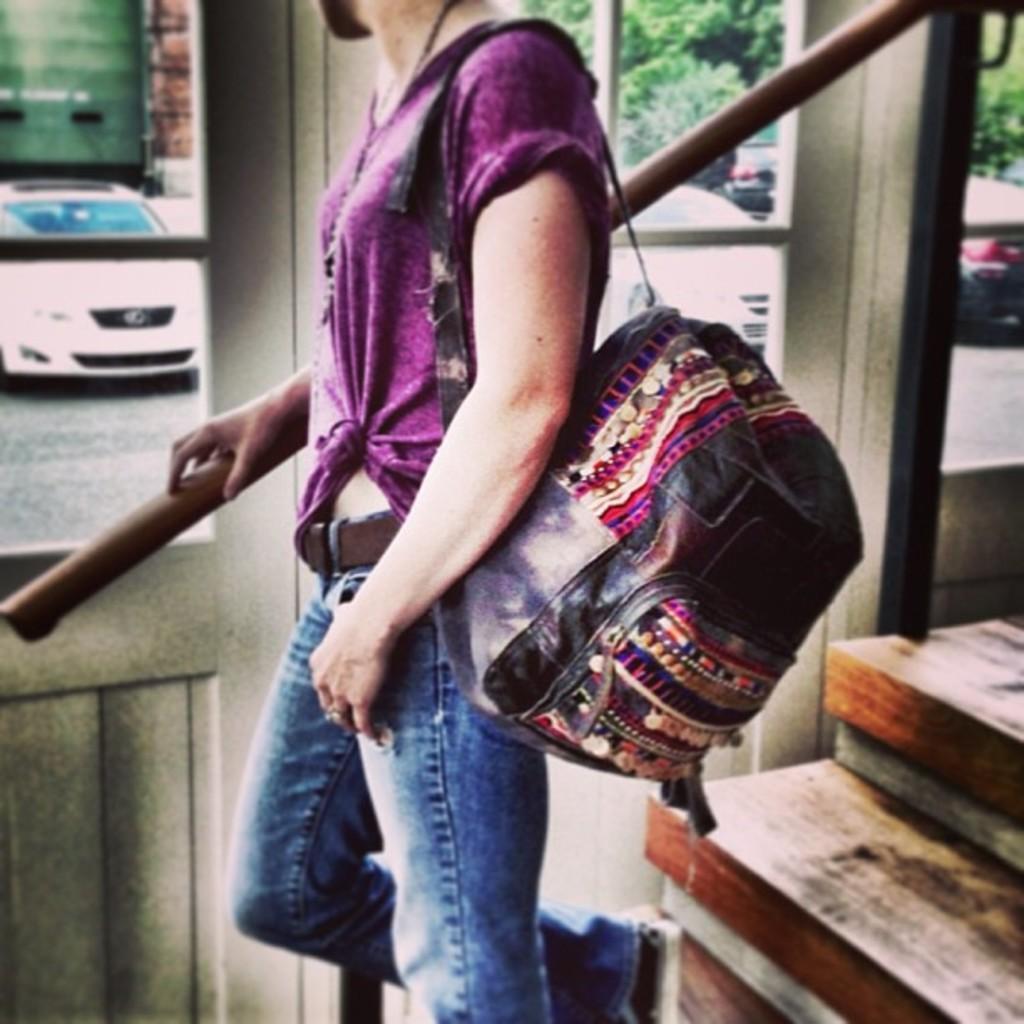Please provide a concise description of this image. This person wore bag. Through this glass windows we can see trees and vehicles. 